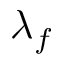Convert formula to latex. <formula><loc_0><loc_0><loc_500><loc_500>\lambda _ { f }</formula> 